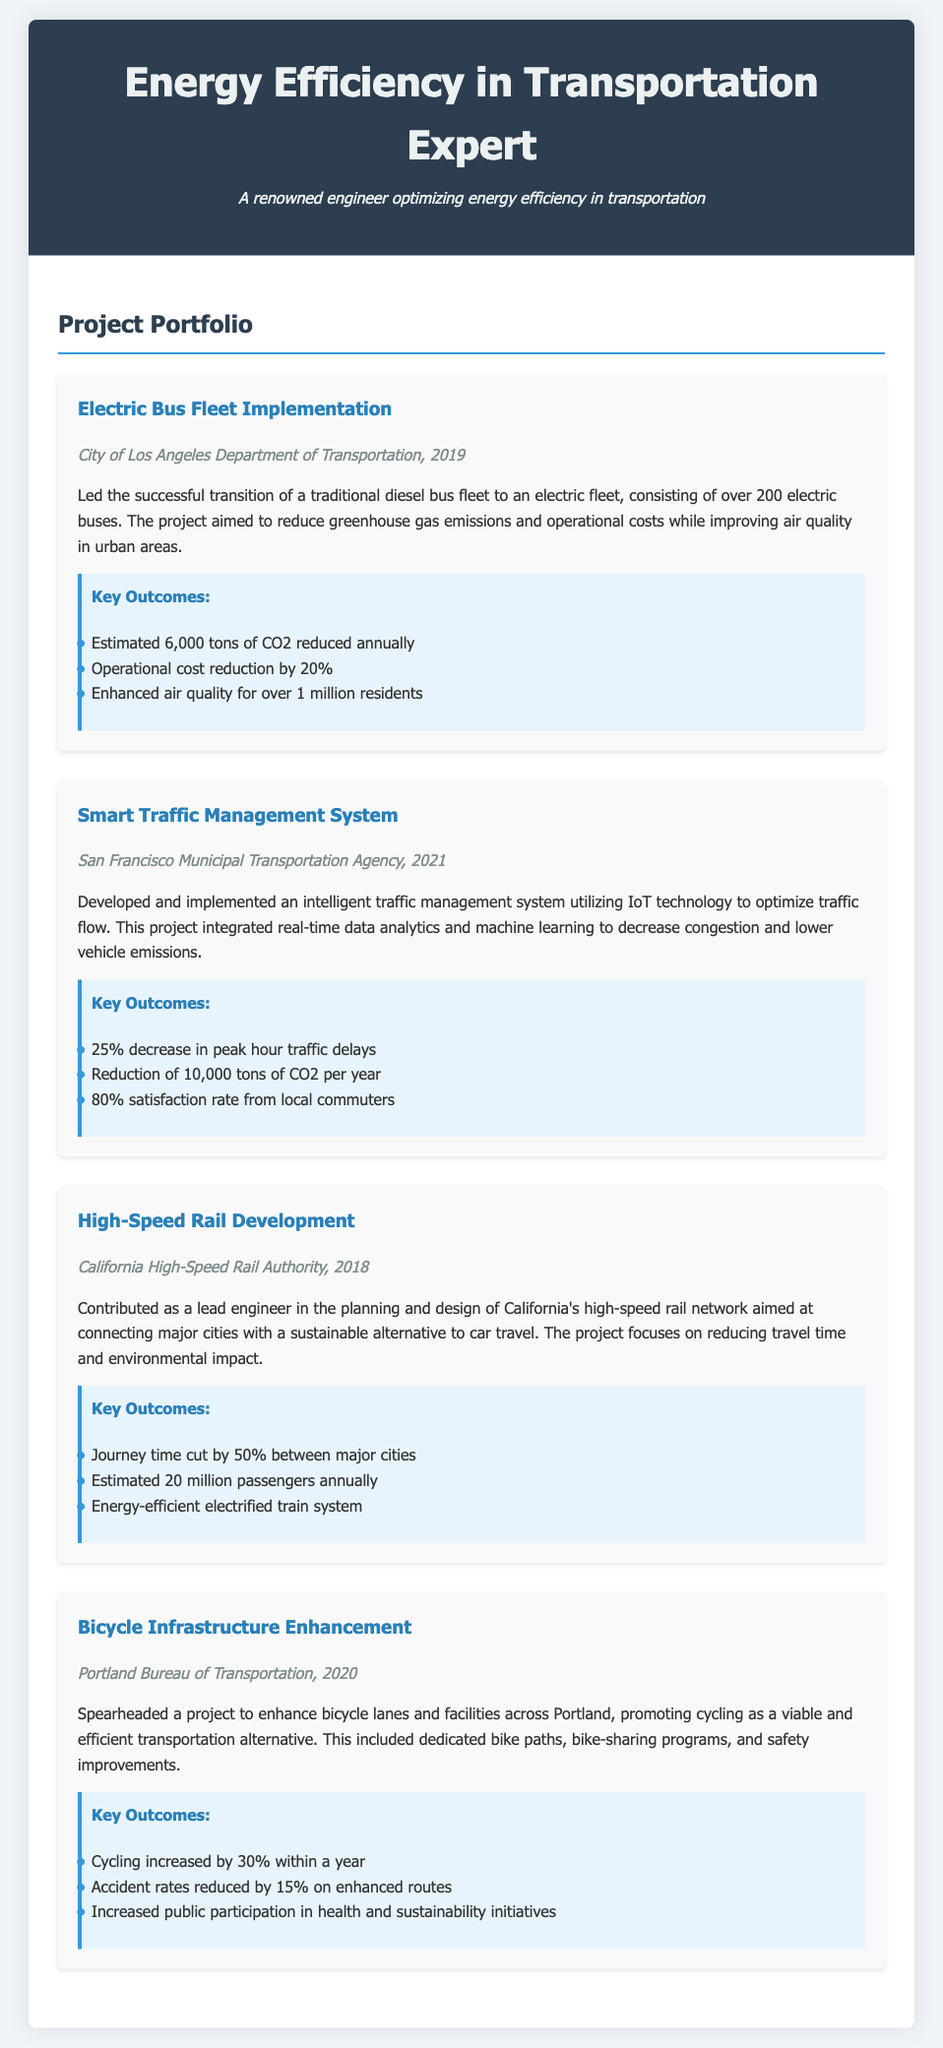What is the project title for the 2019 initiative? The project titled "Electric Bus Fleet Implementation" is mentioned as the 2019 initiative.
Answer: Electric Bus Fleet Implementation Which city was the Smart Traffic Management System implemented in? The document states that the Smart Traffic Management System was implemented in San Francisco.
Answer: San Francisco How many electric buses were included in the Electric Bus Fleet Implementation? The project involved the transition to an electric fleet consisting of over 200 electric buses.
Answer: Over 200 What was the percentage reduction in accident rates on enhanced bicycle routes? The document indicates a 15% reduction in accident rates on the enhanced routes.
Answer: 15% What is the estimated annual passenger count for the High-Speed Rail Development? The estimated annual passenger count for the High-Speed Rail Development is 20 million passengers.
Answer: 20 million What was the operational cost reduction percentage achieved in the Electric Bus Fleet Implementation? The operational cost was reduced by 20% as stated in the project outcomes.
Answer: 20% In what year was the Bicycle Infrastructure Enhancement project initiated? The Bicycle Infrastructure Enhancement project was initiated in 2020.
Answer: 2020 What technology was utilized in the Smart Traffic Management System? The Smart Traffic Management System utilized IoT technology for its operations.
Answer: IoT technology What was the satisfaction rate from local commuters for the Smart Traffic Management System? The satisfaction rate from local commuters was noted as 80%.
Answer: 80% 